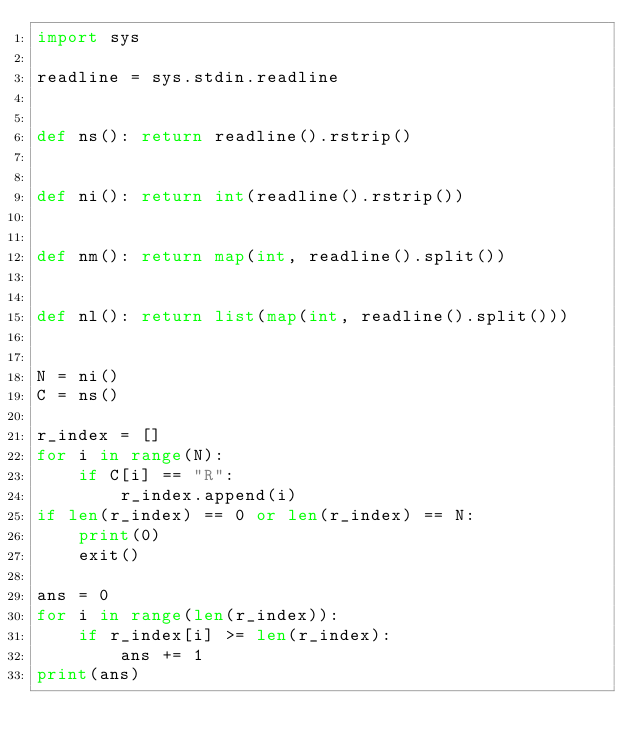Convert code to text. <code><loc_0><loc_0><loc_500><loc_500><_Python_>import sys

readline = sys.stdin.readline


def ns(): return readline().rstrip()


def ni(): return int(readline().rstrip())


def nm(): return map(int, readline().split())


def nl(): return list(map(int, readline().split()))


N = ni()
C = ns()

r_index = []
for i in range(N):
    if C[i] == "R":
        r_index.append(i)
if len(r_index) == 0 or len(r_index) == N:
    print(0)
    exit()

ans = 0
for i in range(len(r_index)):
    if r_index[i] >= len(r_index):
        ans += 1
print(ans)
</code> 